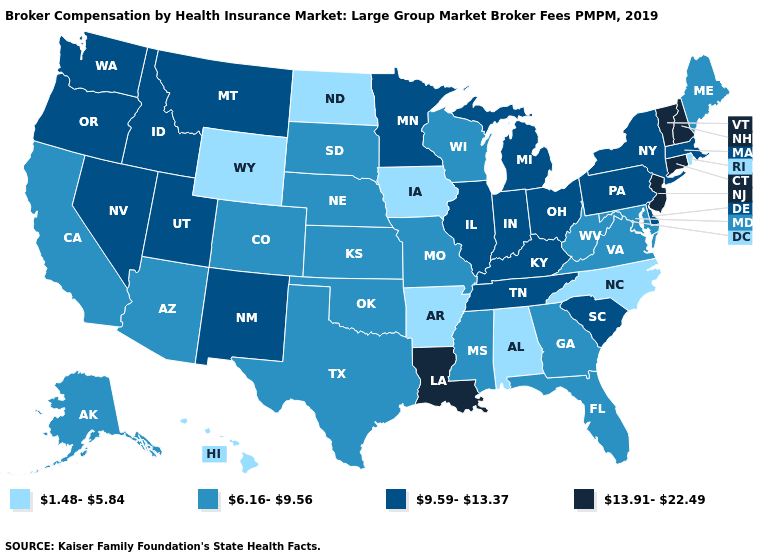What is the highest value in states that border Oregon?
Give a very brief answer. 9.59-13.37. What is the value of Hawaii?
Be succinct. 1.48-5.84. Does Florida have a lower value than Arkansas?
Write a very short answer. No. What is the highest value in states that border Ohio?
Give a very brief answer. 9.59-13.37. Does Iowa have the lowest value in the USA?
Concise answer only. Yes. Name the states that have a value in the range 1.48-5.84?
Quick response, please. Alabama, Arkansas, Hawaii, Iowa, North Carolina, North Dakota, Rhode Island, Wyoming. Is the legend a continuous bar?
Concise answer only. No. Is the legend a continuous bar?
Answer briefly. No. Which states hav the highest value in the West?
Write a very short answer. Idaho, Montana, Nevada, New Mexico, Oregon, Utah, Washington. What is the value of North Dakota?
Keep it brief. 1.48-5.84. Does Tennessee have the same value as Montana?
Concise answer only. Yes. Name the states that have a value in the range 13.91-22.49?
Concise answer only. Connecticut, Louisiana, New Hampshire, New Jersey, Vermont. Name the states that have a value in the range 9.59-13.37?
Answer briefly. Delaware, Idaho, Illinois, Indiana, Kentucky, Massachusetts, Michigan, Minnesota, Montana, Nevada, New Mexico, New York, Ohio, Oregon, Pennsylvania, South Carolina, Tennessee, Utah, Washington. How many symbols are there in the legend?
Concise answer only. 4. What is the value of Washington?
Short answer required. 9.59-13.37. 